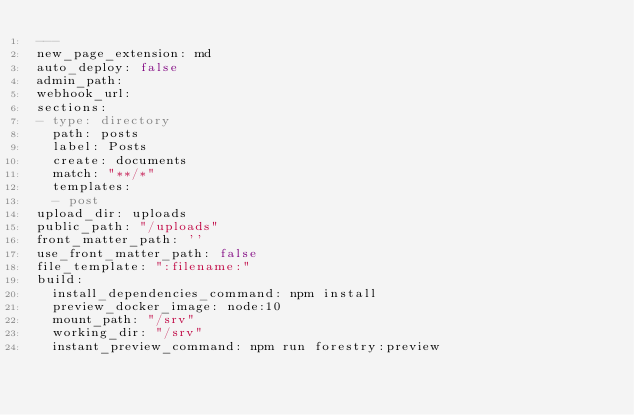Convert code to text. <code><loc_0><loc_0><loc_500><loc_500><_YAML_>---
new_page_extension: md
auto_deploy: false
admin_path: 
webhook_url: 
sections:
- type: directory
  path: posts
  label: Posts
  create: documents
  match: "**/*"
  templates:
  - post
upload_dir: uploads
public_path: "/uploads"
front_matter_path: ''
use_front_matter_path: false
file_template: ":filename:"
build:
  install_dependencies_command: npm install
  preview_docker_image: node:10
  mount_path: "/srv"
  working_dir: "/srv"
  instant_preview_command: npm run forestry:preview
</code> 